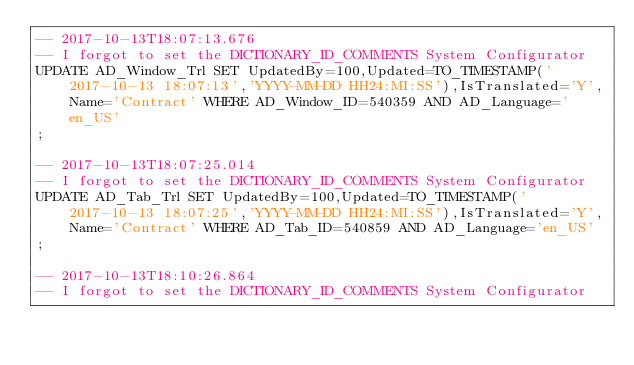<code> <loc_0><loc_0><loc_500><loc_500><_SQL_>-- 2017-10-13T18:07:13.676
-- I forgot to set the DICTIONARY_ID_COMMENTS System Configurator
UPDATE AD_Window_Trl SET UpdatedBy=100,Updated=TO_TIMESTAMP('2017-10-13 18:07:13','YYYY-MM-DD HH24:MI:SS'),IsTranslated='Y',Name='Contract' WHERE AD_Window_ID=540359 AND AD_Language='en_US'
;

-- 2017-10-13T18:07:25.014
-- I forgot to set the DICTIONARY_ID_COMMENTS System Configurator
UPDATE AD_Tab_Trl SET UpdatedBy=100,Updated=TO_TIMESTAMP('2017-10-13 18:07:25','YYYY-MM-DD HH24:MI:SS'),IsTranslated='Y',Name='Contract' WHERE AD_Tab_ID=540859 AND AD_Language='en_US'
;

-- 2017-10-13T18:10:26.864
-- I forgot to set the DICTIONARY_ID_COMMENTS System Configurator</code> 